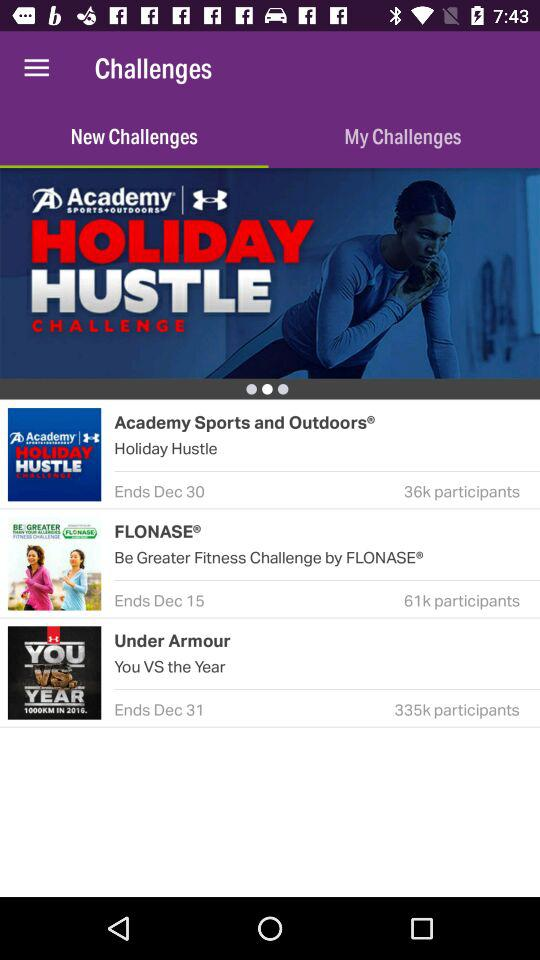What do the new challenges include? The new challenges include "Academy Sports and Outdoors®", "FLONASE®" and "Under Armour". 